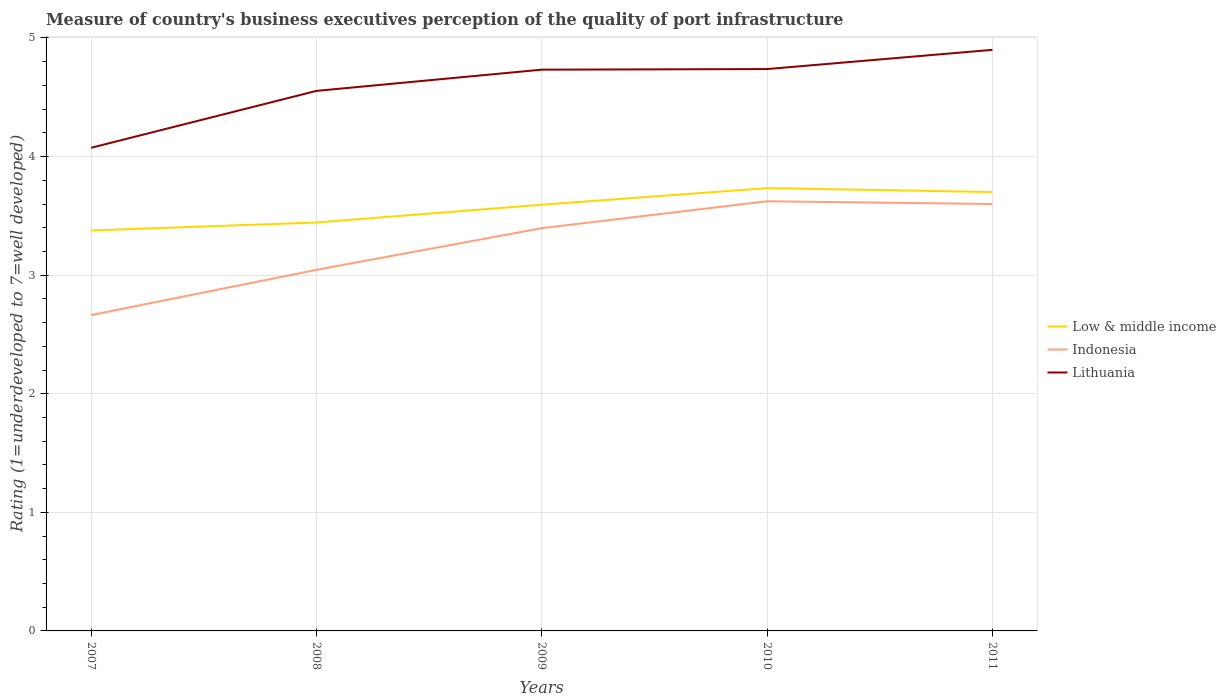How many different coloured lines are there?
Offer a very short reply. 3. Does the line corresponding to Indonesia intersect with the line corresponding to Low & middle income?
Your answer should be very brief. No. Across all years, what is the maximum ratings of the quality of port infrastructure in Indonesia?
Your response must be concise. 2.66. In which year was the ratings of the quality of port infrastructure in Lithuania maximum?
Ensure brevity in your answer.  2007. What is the total ratings of the quality of port infrastructure in Low & middle income in the graph?
Your response must be concise. -0.15. What is the difference between the highest and the second highest ratings of the quality of port infrastructure in Lithuania?
Provide a succinct answer. 0.83. What is the difference between the highest and the lowest ratings of the quality of port infrastructure in Indonesia?
Offer a very short reply. 3. How many years are there in the graph?
Provide a short and direct response. 5. Does the graph contain any zero values?
Your response must be concise. No. Where does the legend appear in the graph?
Your answer should be very brief. Center right. How are the legend labels stacked?
Your response must be concise. Vertical. What is the title of the graph?
Make the answer very short. Measure of country's business executives perception of the quality of port infrastructure. What is the label or title of the Y-axis?
Ensure brevity in your answer.  Rating (1=underdeveloped to 7=well developed). What is the Rating (1=underdeveloped to 7=well developed) of Low & middle income in 2007?
Provide a short and direct response. 3.38. What is the Rating (1=underdeveloped to 7=well developed) in Indonesia in 2007?
Ensure brevity in your answer.  2.66. What is the Rating (1=underdeveloped to 7=well developed) in Lithuania in 2007?
Offer a terse response. 4.07. What is the Rating (1=underdeveloped to 7=well developed) of Low & middle income in 2008?
Provide a succinct answer. 3.44. What is the Rating (1=underdeveloped to 7=well developed) of Indonesia in 2008?
Your answer should be compact. 3.04. What is the Rating (1=underdeveloped to 7=well developed) of Lithuania in 2008?
Your answer should be very brief. 4.55. What is the Rating (1=underdeveloped to 7=well developed) of Low & middle income in 2009?
Your answer should be very brief. 3.59. What is the Rating (1=underdeveloped to 7=well developed) in Indonesia in 2009?
Your answer should be very brief. 3.4. What is the Rating (1=underdeveloped to 7=well developed) of Lithuania in 2009?
Your answer should be compact. 4.73. What is the Rating (1=underdeveloped to 7=well developed) of Low & middle income in 2010?
Offer a terse response. 3.73. What is the Rating (1=underdeveloped to 7=well developed) of Indonesia in 2010?
Make the answer very short. 3.62. What is the Rating (1=underdeveloped to 7=well developed) of Lithuania in 2010?
Provide a succinct answer. 4.74. What is the Rating (1=underdeveloped to 7=well developed) of Low & middle income in 2011?
Provide a short and direct response. 3.7. Across all years, what is the maximum Rating (1=underdeveloped to 7=well developed) in Low & middle income?
Provide a succinct answer. 3.73. Across all years, what is the maximum Rating (1=underdeveloped to 7=well developed) of Indonesia?
Your response must be concise. 3.62. Across all years, what is the minimum Rating (1=underdeveloped to 7=well developed) of Low & middle income?
Provide a succinct answer. 3.38. Across all years, what is the minimum Rating (1=underdeveloped to 7=well developed) of Indonesia?
Make the answer very short. 2.66. Across all years, what is the minimum Rating (1=underdeveloped to 7=well developed) in Lithuania?
Offer a very short reply. 4.07. What is the total Rating (1=underdeveloped to 7=well developed) of Low & middle income in the graph?
Provide a succinct answer. 17.85. What is the total Rating (1=underdeveloped to 7=well developed) of Indonesia in the graph?
Make the answer very short. 16.33. What is the total Rating (1=underdeveloped to 7=well developed) of Lithuania in the graph?
Ensure brevity in your answer.  23. What is the difference between the Rating (1=underdeveloped to 7=well developed) in Low & middle income in 2007 and that in 2008?
Ensure brevity in your answer.  -0.07. What is the difference between the Rating (1=underdeveloped to 7=well developed) of Indonesia in 2007 and that in 2008?
Offer a very short reply. -0.38. What is the difference between the Rating (1=underdeveloped to 7=well developed) of Lithuania in 2007 and that in 2008?
Your response must be concise. -0.48. What is the difference between the Rating (1=underdeveloped to 7=well developed) of Low & middle income in 2007 and that in 2009?
Provide a succinct answer. -0.22. What is the difference between the Rating (1=underdeveloped to 7=well developed) of Indonesia in 2007 and that in 2009?
Offer a terse response. -0.73. What is the difference between the Rating (1=underdeveloped to 7=well developed) of Lithuania in 2007 and that in 2009?
Your answer should be compact. -0.66. What is the difference between the Rating (1=underdeveloped to 7=well developed) in Low & middle income in 2007 and that in 2010?
Your response must be concise. -0.36. What is the difference between the Rating (1=underdeveloped to 7=well developed) in Indonesia in 2007 and that in 2010?
Your response must be concise. -0.96. What is the difference between the Rating (1=underdeveloped to 7=well developed) of Lithuania in 2007 and that in 2010?
Offer a very short reply. -0.66. What is the difference between the Rating (1=underdeveloped to 7=well developed) in Low & middle income in 2007 and that in 2011?
Offer a very short reply. -0.32. What is the difference between the Rating (1=underdeveloped to 7=well developed) in Indonesia in 2007 and that in 2011?
Keep it short and to the point. -0.94. What is the difference between the Rating (1=underdeveloped to 7=well developed) of Lithuania in 2007 and that in 2011?
Provide a succinct answer. -0.83. What is the difference between the Rating (1=underdeveloped to 7=well developed) of Low & middle income in 2008 and that in 2009?
Ensure brevity in your answer.  -0.15. What is the difference between the Rating (1=underdeveloped to 7=well developed) in Indonesia in 2008 and that in 2009?
Offer a very short reply. -0.35. What is the difference between the Rating (1=underdeveloped to 7=well developed) in Lithuania in 2008 and that in 2009?
Provide a short and direct response. -0.18. What is the difference between the Rating (1=underdeveloped to 7=well developed) of Low & middle income in 2008 and that in 2010?
Your answer should be compact. -0.29. What is the difference between the Rating (1=underdeveloped to 7=well developed) in Indonesia in 2008 and that in 2010?
Provide a succinct answer. -0.58. What is the difference between the Rating (1=underdeveloped to 7=well developed) in Lithuania in 2008 and that in 2010?
Provide a succinct answer. -0.18. What is the difference between the Rating (1=underdeveloped to 7=well developed) of Low & middle income in 2008 and that in 2011?
Make the answer very short. -0.26. What is the difference between the Rating (1=underdeveloped to 7=well developed) of Indonesia in 2008 and that in 2011?
Your answer should be compact. -0.56. What is the difference between the Rating (1=underdeveloped to 7=well developed) of Lithuania in 2008 and that in 2011?
Ensure brevity in your answer.  -0.35. What is the difference between the Rating (1=underdeveloped to 7=well developed) of Low & middle income in 2009 and that in 2010?
Offer a terse response. -0.14. What is the difference between the Rating (1=underdeveloped to 7=well developed) of Indonesia in 2009 and that in 2010?
Make the answer very short. -0.23. What is the difference between the Rating (1=underdeveloped to 7=well developed) in Lithuania in 2009 and that in 2010?
Provide a succinct answer. -0.01. What is the difference between the Rating (1=underdeveloped to 7=well developed) of Low & middle income in 2009 and that in 2011?
Your answer should be compact. -0.11. What is the difference between the Rating (1=underdeveloped to 7=well developed) in Indonesia in 2009 and that in 2011?
Your response must be concise. -0.2. What is the difference between the Rating (1=underdeveloped to 7=well developed) of Lithuania in 2009 and that in 2011?
Your answer should be very brief. -0.17. What is the difference between the Rating (1=underdeveloped to 7=well developed) in Low & middle income in 2010 and that in 2011?
Your answer should be compact. 0.03. What is the difference between the Rating (1=underdeveloped to 7=well developed) of Indonesia in 2010 and that in 2011?
Your answer should be compact. 0.02. What is the difference between the Rating (1=underdeveloped to 7=well developed) of Lithuania in 2010 and that in 2011?
Your answer should be compact. -0.16. What is the difference between the Rating (1=underdeveloped to 7=well developed) of Low & middle income in 2007 and the Rating (1=underdeveloped to 7=well developed) of Indonesia in 2008?
Your answer should be very brief. 0.33. What is the difference between the Rating (1=underdeveloped to 7=well developed) of Low & middle income in 2007 and the Rating (1=underdeveloped to 7=well developed) of Lithuania in 2008?
Your answer should be compact. -1.18. What is the difference between the Rating (1=underdeveloped to 7=well developed) in Indonesia in 2007 and the Rating (1=underdeveloped to 7=well developed) in Lithuania in 2008?
Provide a succinct answer. -1.89. What is the difference between the Rating (1=underdeveloped to 7=well developed) in Low & middle income in 2007 and the Rating (1=underdeveloped to 7=well developed) in Indonesia in 2009?
Your answer should be very brief. -0.02. What is the difference between the Rating (1=underdeveloped to 7=well developed) in Low & middle income in 2007 and the Rating (1=underdeveloped to 7=well developed) in Lithuania in 2009?
Your answer should be very brief. -1.36. What is the difference between the Rating (1=underdeveloped to 7=well developed) of Indonesia in 2007 and the Rating (1=underdeveloped to 7=well developed) of Lithuania in 2009?
Make the answer very short. -2.07. What is the difference between the Rating (1=underdeveloped to 7=well developed) in Low & middle income in 2007 and the Rating (1=underdeveloped to 7=well developed) in Indonesia in 2010?
Ensure brevity in your answer.  -0.25. What is the difference between the Rating (1=underdeveloped to 7=well developed) in Low & middle income in 2007 and the Rating (1=underdeveloped to 7=well developed) in Lithuania in 2010?
Offer a terse response. -1.36. What is the difference between the Rating (1=underdeveloped to 7=well developed) in Indonesia in 2007 and the Rating (1=underdeveloped to 7=well developed) in Lithuania in 2010?
Provide a succinct answer. -2.07. What is the difference between the Rating (1=underdeveloped to 7=well developed) in Low & middle income in 2007 and the Rating (1=underdeveloped to 7=well developed) in Indonesia in 2011?
Ensure brevity in your answer.  -0.22. What is the difference between the Rating (1=underdeveloped to 7=well developed) in Low & middle income in 2007 and the Rating (1=underdeveloped to 7=well developed) in Lithuania in 2011?
Provide a succinct answer. -1.52. What is the difference between the Rating (1=underdeveloped to 7=well developed) in Indonesia in 2007 and the Rating (1=underdeveloped to 7=well developed) in Lithuania in 2011?
Your answer should be compact. -2.24. What is the difference between the Rating (1=underdeveloped to 7=well developed) of Low & middle income in 2008 and the Rating (1=underdeveloped to 7=well developed) of Indonesia in 2009?
Ensure brevity in your answer.  0.05. What is the difference between the Rating (1=underdeveloped to 7=well developed) in Low & middle income in 2008 and the Rating (1=underdeveloped to 7=well developed) in Lithuania in 2009?
Ensure brevity in your answer.  -1.29. What is the difference between the Rating (1=underdeveloped to 7=well developed) in Indonesia in 2008 and the Rating (1=underdeveloped to 7=well developed) in Lithuania in 2009?
Your answer should be compact. -1.69. What is the difference between the Rating (1=underdeveloped to 7=well developed) of Low & middle income in 2008 and the Rating (1=underdeveloped to 7=well developed) of Indonesia in 2010?
Give a very brief answer. -0.18. What is the difference between the Rating (1=underdeveloped to 7=well developed) of Low & middle income in 2008 and the Rating (1=underdeveloped to 7=well developed) of Lithuania in 2010?
Ensure brevity in your answer.  -1.29. What is the difference between the Rating (1=underdeveloped to 7=well developed) in Indonesia in 2008 and the Rating (1=underdeveloped to 7=well developed) in Lithuania in 2010?
Provide a succinct answer. -1.69. What is the difference between the Rating (1=underdeveloped to 7=well developed) of Low & middle income in 2008 and the Rating (1=underdeveloped to 7=well developed) of Indonesia in 2011?
Ensure brevity in your answer.  -0.16. What is the difference between the Rating (1=underdeveloped to 7=well developed) in Low & middle income in 2008 and the Rating (1=underdeveloped to 7=well developed) in Lithuania in 2011?
Make the answer very short. -1.46. What is the difference between the Rating (1=underdeveloped to 7=well developed) in Indonesia in 2008 and the Rating (1=underdeveloped to 7=well developed) in Lithuania in 2011?
Your answer should be compact. -1.86. What is the difference between the Rating (1=underdeveloped to 7=well developed) of Low & middle income in 2009 and the Rating (1=underdeveloped to 7=well developed) of Indonesia in 2010?
Your response must be concise. -0.03. What is the difference between the Rating (1=underdeveloped to 7=well developed) in Low & middle income in 2009 and the Rating (1=underdeveloped to 7=well developed) in Lithuania in 2010?
Give a very brief answer. -1.14. What is the difference between the Rating (1=underdeveloped to 7=well developed) of Indonesia in 2009 and the Rating (1=underdeveloped to 7=well developed) of Lithuania in 2010?
Your answer should be compact. -1.34. What is the difference between the Rating (1=underdeveloped to 7=well developed) of Low & middle income in 2009 and the Rating (1=underdeveloped to 7=well developed) of Indonesia in 2011?
Offer a very short reply. -0.01. What is the difference between the Rating (1=underdeveloped to 7=well developed) of Low & middle income in 2009 and the Rating (1=underdeveloped to 7=well developed) of Lithuania in 2011?
Keep it short and to the point. -1.31. What is the difference between the Rating (1=underdeveloped to 7=well developed) in Indonesia in 2009 and the Rating (1=underdeveloped to 7=well developed) in Lithuania in 2011?
Your answer should be very brief. -1.5. What is the difference between the Rating (1=underdeveloped to 7=well developed) in Low & middle income in 2010 and the Rating (1=underdeveloped to 7=well developed) in Indonesia in 2011?
Ensure brevity in your answer.  0.13. What is the difference between the Rating (1=underdeveloped to 7=well developed) in Low & middle income in 2010 and the Rating (1=underdeveloped to 7=well developed) in Lithuania in 2011?
Your answer should be compact. -1.17. What is the difference between the Rating (1=underdeveloped to 7=well developed) in Indonesia in 2010 and the Rating (1=underdeveloped to 7=well developed) in Lithuania in 2011?
Keep it short and to the point. -1.28. What is the average Rating (1=underdeveloped to 7=well developed) of Low & middle income per year?
Keep it short and to the point. 3.57. What is the average Rating (1=underdeveloped to 7=well developed) of Indonesia per year?
Your answer should be compact. 3.27. What is the average Rating (1=underdeveloped to 7=well developed) in Lithuania per year?
Provide a short and direct response. 4.6. In the year 2007, what is the difference between the Rating (1=underdeveloped to 7=well developed) of Low & middle income and Rating (1=underdeveloped to 7=well developed) of Indonesia?
Offer a very short reply. 0.71. In the year 2007, what is the difference between the Rating (1=underdeveloped to 7=well developed) in Low & middle income and Rating (1=underdeveloped to 7=well developed) in Lithuania?
Ensure brevity in your answer.  -0.7. In the year 2007, what is the difference between the Rating (1=underdeveloped to 7=well developed) in Indonesia and Rating (1=underdeveloped to 7=well developed) in Lithuania?
Your answer should be very brief. -1.41. In the year 2008, what is the difference between the Rating (1=underdeveloped to 7=well developed) in Low & middle income and Rating (1=underdeveloped to 7=well developed) in Indonesia?
Give a very brief answer. 0.4. In the year 2008, what is the difference between the Rating (1=underdeveloped to 7=well developed) of Low & middle income and Rating (1=underdeveloped to 7=well developed) of Lithuania?
Your answer should be very brief. -1.11. In the year 2008, what is the difference between the Rating (1=underdeveloped to 7=well developed) in Indonesia and Rating (1=underdeveloped to 7=well developed) in Lithuania?
Provide a succinct answer. -1.51. In the year 2009, what is the difference between the Rating (1=underdeveloped to 7=well developed) in Low & middle income and Rating (1=underdeveloped to 7=well developed) in Indonesia?
Make the answer very short. 0.2. In the year 2009, what is the difference between the Rating (1=underdeveloped to 7=well developed) in Low & middle income and Rating (1=underdeveloped to 7=well developed) in Lithuania?
Offer a very short reply. -1.14. In the year 2009, what is the difference between the Rating (1=underdeveloped to 7=well developed) in Indonesia and Rating (1=underdeveloped to 7=well developed) in Lithuania?
Your response must be concise. -1.34. In the year 2010, what is the difference between the Rating (1=underdeveloped to 7=well developed) in Low & middle income and Rating (1=underdeveloped to 7=well developed) in Indonesia?
Give a very brief answer. 0.11. In the year 2010, what is the difference between the Rating (1=underdeveloped to 7=well developed) in Low & middle income and Rating (1=underdeveloped to 7=well developed) in Lithuania?
Offer a terse response. -1. In the year 2010, what is the difference between the Rating (1=underdeveloped to 7=well developed) in Indonesia and Rating (1=underdeveloped to 7=well developed) in Lithuania?
Give a very brief answer. -1.11. In the year 2011, what is the difference between the Rating (1=underdeveloped to 7=well developed) in Low & middle income and Rating (1=underdeveloped to 7=well developed) in Indonesia?
Offer a very short reply. 0.1. In the year 2011, what is the difference between the Rating (1=underdeveloped to 7=well developed) in Low & middle income and Rating (1=underdeveloped to 7=well developed) in Lithuania?
Give a very brief answer. -1.2. In the year 2011, what is the difference between the Rating (1=underdeveloped to 7=well developed) in Indonesia and Rating (1=underdeveloped to 7=well developed) in Lithuania?
Give a very brief answer. -1.3. What is the ratio of the Rating (1=underdeveloped to 7=well developed) in Low & middle income in 2007 to that in 2008?
Make the answer very short. 0.98. What is the ratio of the Rating (1=underdeveloped to 7=well developed) of Indonesia in 2007 to that in 2008?
Ensure brevity in your answer.  0.87. What is the ratio of the Rating (1=underdeveloped to 7=well developed) in Lithuania in 2007 to that in 2008?
Your response must be concise. 0.89. What is the ratio of the Rating (1=underdeveloped to 7=well developed) in Low & middle income in 2007 to that in 2009?
Ensure brevity in your answer.  0.94. What is the ratio of the Rating (1=underdeveloped to 7=well developed) in Indonesia in 2007 to that in 2009?
Your response must be concise. 0.78. What is the ratio of the Rating (1=underdeveloped to 7=well developed) of Lithuania in 2007 to that in 2009?
Your answer should be very brief. 0.86. What is the ratio of the Rating (1=underdeveloped to 7=well developed) in Low & middle income in 2007 to that in 2010?
Give a very brief answer. 0.9. What is the ratio of the Rating (1=underdeveloped to 7=well developed) in Indonesia in 2007 to that in 2010?
Offer a very short reply. 0.73. What is the ratio of the Rating (1=underdeveloped to 7=well developed) of Lithuania in 2007 to that in 2010?
Offer a terse response. 0.86. What is the ratio of the Rating (1=underdeveloped to 7=well developed) of Low & middle income in 2007 to that in 2011?
Your answer should be very brief. 0.91. What is the ratio of the Rating (1=underdeveloped to 7=well developed) of Indonesia in 2007 to that in 2011?
Offer a terse response. 0.74. What is the ratio of the Rating (1=underdeveloped to 7=well developed) of Lithuania in 2007 to that in 2011?
Provide a short and direct response. 0.83. What is the ratio of the Rating (1=underdeveloped to 7=well developed) of Indonesia in 2008 to that in 2009?
Your answer should be compact. 0.9. What is the ratio of the Rating (1=underdeveloped to 7=well developed) in Lithuania in 2008 to that in 2009?
Offer a terse response. 0.96. What is the ratio of the Rating (1=underdeveloped to 7=well developed) in Low & middle income in 2008 to that in 2010?
Provide a short and direct response. 0.92. What is the ratio of the Rating (1=underdeveloped to 7=well developed) in Indonesia in 2008 to that in 2010?
Ensure brevity in your answer.  0.84. What is the ratio of the Rating (1=underdeveloped to 7=well developed) of Lithuania in 2008 to that in 2010?
Ensure brevity in your answer.  0.96. What is the ratio of the Rating (1=underdeveloped to 7=well developed) in Low & middle income in 2008 to that in 2011?
Offer a terse response. 0.93. What is the ratio of the Rating (1=underdeveloped to 7=well developed) of Indonesia in 2008 to that in 2011?
Your answer should be compact. 0.85. What is the ratio of the Rating (1=underdeveloped to 7=well developed) of Lithuania in 2008 to that in 2011?
Your answer should be very brief. 0.93. What is the ratio of the Rating (1=underdeveloped to 7=well developed) in Low & middle income in 2009 to that in 2010?
Your answer should be compact. 0.96. What is the ratio of the Rating (1=underdeveloped to 7=well developed) in Indonesia in 2009 to that in 2010?
Provide a short and direct response. 0.94. What is the ratio of the Rating (1=underdeveloped to 7=well developed) in Lithuania in 2009 to that in 2010?
Ensure brevity in your answer.  1. What is the ratio of the Rating (1=underdeveloped to 7=well developed) of Low & middle income in 2009 to that in 2011?
Provide a short and direct response. 0.97. What is the ratio of the Rating (1=underdeveloped to 7=well developed) of Indonesia in 2009 to that in 2011?
Make the answer very short. 0.94. What is the ratio of the Rating (1=underdeveloped to 7=well developed) in Lithuania in 2009 to that in 2011?
Offer a terse response. 0.97. What is the ratio of the Rating (1=underdeveloped to 7=well developed) of Low & middle income in 2010 to that in 2011?
Provide a succinct answer. 1.01. What is the ratio of the Rating (1=underdeveloped to 7=well developed) of Indonesia in 2010 to that in 2011?
Offer a very short reply. 1.01. What is the ratio of the Rating (1=underdeveloped to 7=well developed) of Lithuania in 2010 to that in 2011?
Offer a very short reply. 0.97. What is the difference between the highest and the second highest Rating (1=underdeveloped to 7=well developed) of Low & middle income?
Ensure brevity in your answer.  0.03. What is the difference between the highest and the second highest Rating (1=underdeveloped to 7=well developed) in Indonesia?
Your answer should be compact. 0.02. What is the difference between the highest and the second highest Rating (1=underdeveloped to 7=well developed) in Lithuania?
Provide a succinct answer. 0.16. What is the difference between the highest and the lowest Rating (1=underdeveloped to 7=well developed) of Low & middle income?
Provide a short and direct response. 0.36. What is the difference between the highest and the lowest Rating (1=underdeveloped to 7=well developed) of Indonesia?
Keep it short and to the point. 0.96. What is the difference between the highest and the lowest Rating (1=underdeveloped to 7=well developed) of Lithuania?
Your answer should be compact. 0.83. 